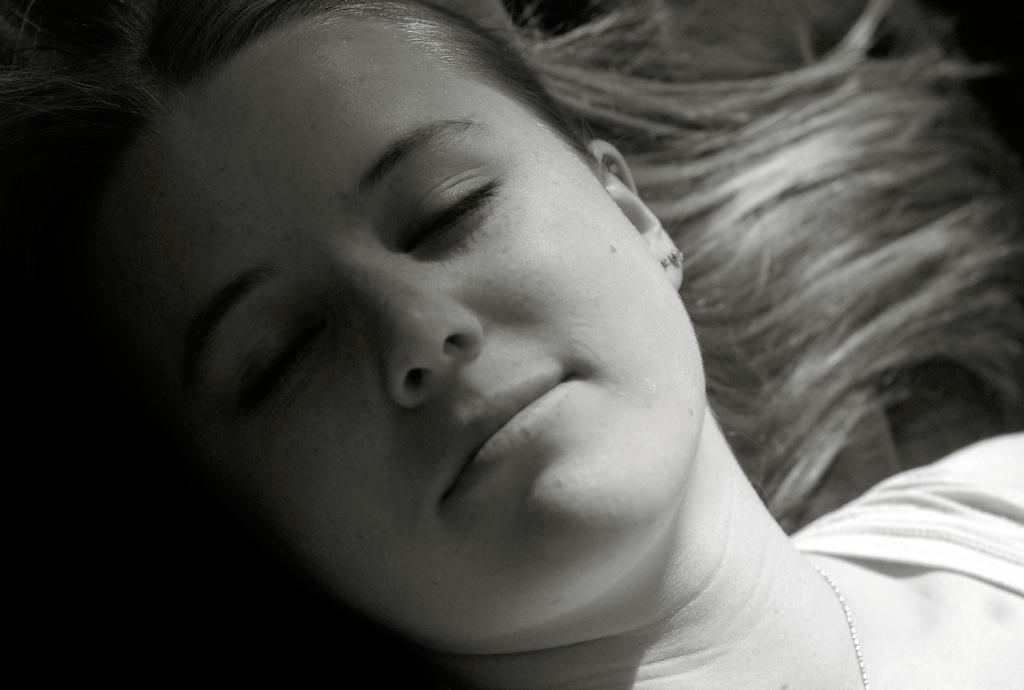Who is present in the image? There is a lady in the image. What quarter is the lady requesting in the image? There is no mention of a quarter or any request in the image; it only features a lady. In which country is the lady located in the image? The image does not provide any information about the country where the lady is located. 